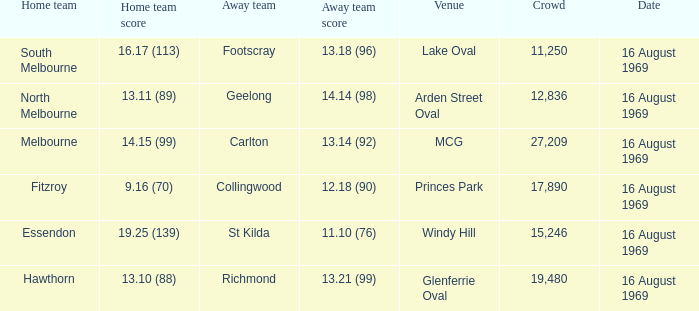What was the away team when the game was at Princes Park? Collingwood. 